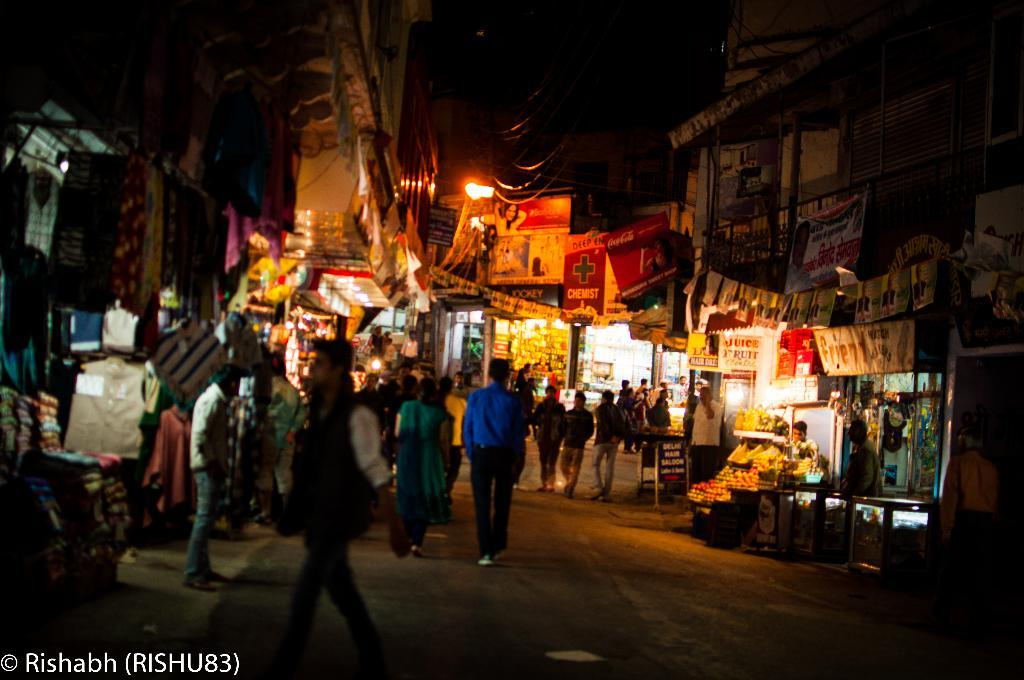What is happening in the image? There are people on the road in the image. What can be seen in the background of the image? There are shops in the background of the image. What is the source of light at the top of the image? There is a light at the top of the image. How many passengers are visible in the image? There is no reference to passengers in the image, as it features people on the road and shops in the background. What type of approval is required for the light at the top of the image? There is no indication in the image that any approval is required for the light at the top of the image. 